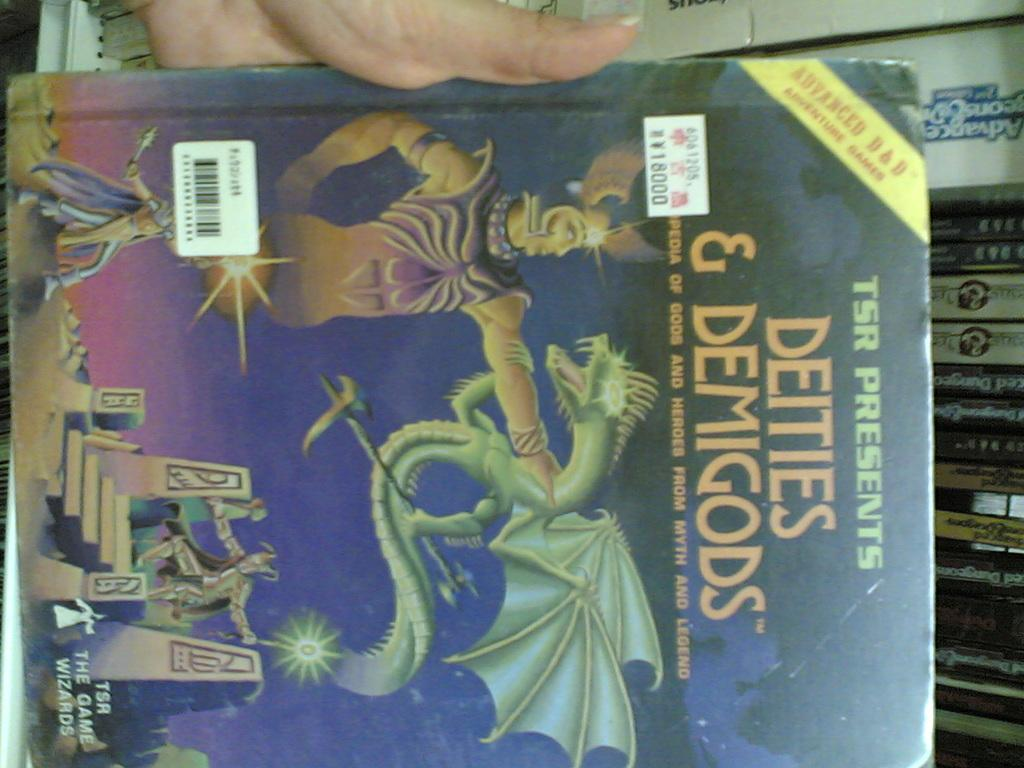<image>
Render a clear and concise summary of the photo. A person holding the book Deities and Demigods. 